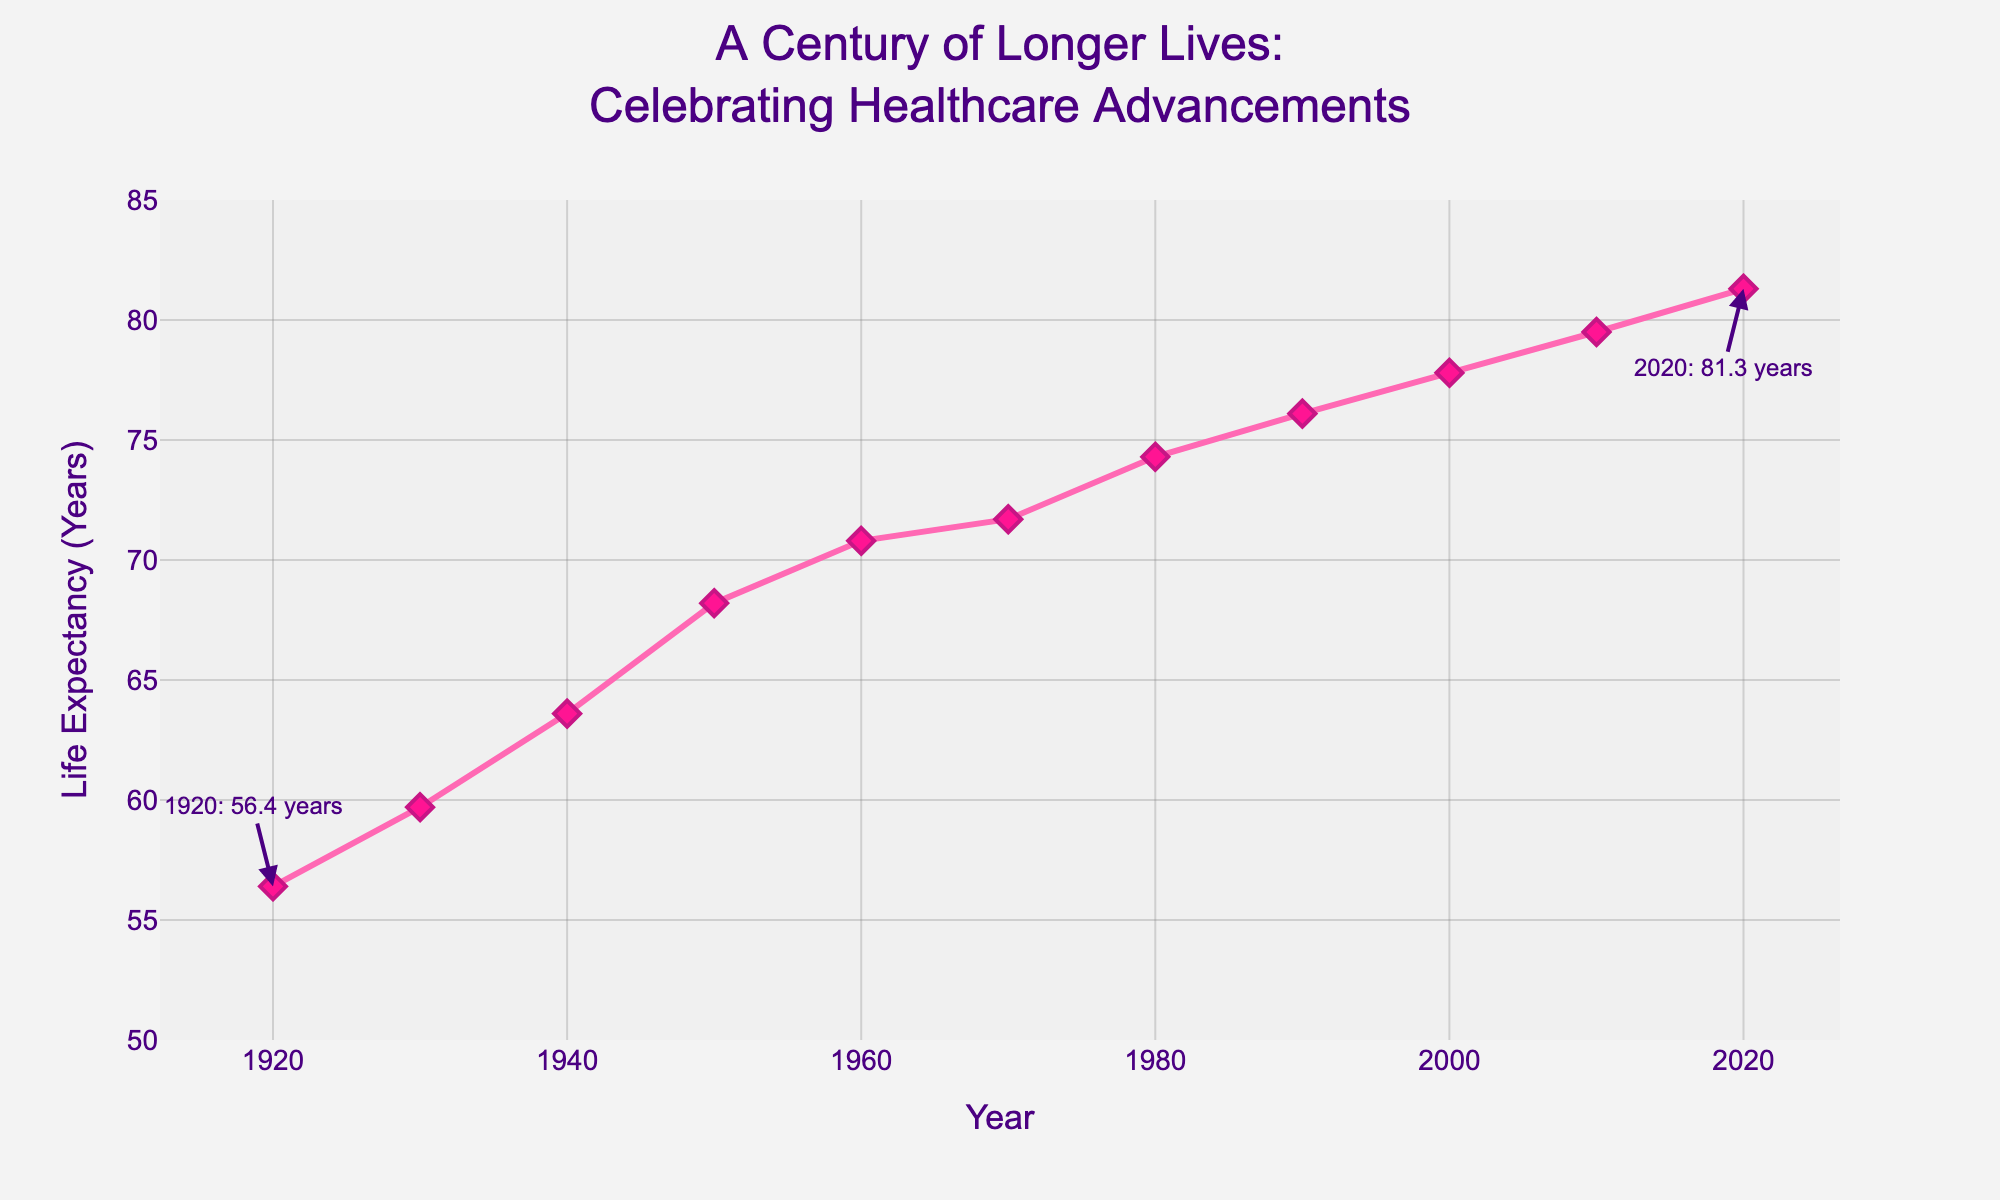Which year shows the highest life expectancy in the plot? We look at the data points and see that the highest life expectancy is shown at the point above the year 2020 with a value of 81.3 years.
Answer: 2020 By how many years did life expectancy increase from 1920 to 1950? In 1920, life expectancy was 56.4 years, and in 1950, it was 68.2 years. The increase is 68.2 - 56.4 = 11.8 years.
Answer: 11.8 years Which decade shows the greatest increase in life expectancy, and what is that increase? Comparing each decade's increase: 1920-1930 (3.3 years), 1930-1940 (3.9 years), 1940-1950 (4.6 years), 1950-1960 (2.6 years), 1960-1970 (0.9 years), 1970-1980 (2.6 years), 1980-1990 (1.8 years), 1990-2000 (1.7 years), 2000-2010 (1.7 years), 2010-2020 (1.8 years). The largest increase is from 1940 to 1950 with an increase of 4.6 years.
Answer: 1940-1950, 4.6 years What is the average life expectancy over the entire century shown in the figure? The data points are 56.4, 59.7, 63.6, 68.2, 70.8, 71.7, 74.3, 76.1, 77.8, 79.5, 81.3. Sum = 779.4, number of points = 11. The average is 779.4 / 11 = 70.85 years.
Answer: 70.85 years Has life expectancy ever decreased in any decade shown? By checking the trend from 1920 to 2020, life expectancy has continually increased without any decrease. The line in the figure shows a consistent upward trend.
Answer: No How does the life expectancy in 1970 compare to that in 2000? In 1970, the life expectancy was 71.7 years and in 2000, it was 77.8 years. By comparison, life expectancy in 2000 is 6.1 years higher than in 1970.
Answer: 6.1 years higher What is the change in life expectancy from 1930 to 2020? The life expectancy in 1930 was 59.7 years and in 2020 it was 81.3 years. The change is 81.3 - 59.7 = 21.6 years.
Answer: 21.6 years Identify the color used for the line representing life expectancy. Observing the figure, the line representing life expectancy is colored pink.
Answer: Pink 